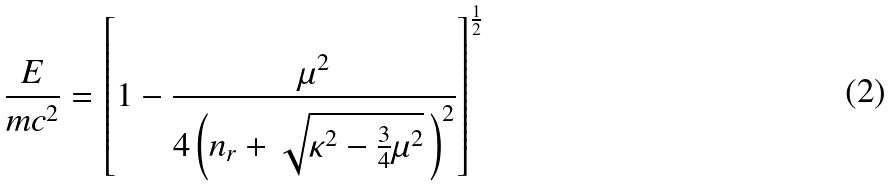<formula> <loc_0><loc_0><loc_500><loc_500>\frac { E } { m c ^ { 2 } } = \left [ 1 - \frac { \mu ^ { 2 } } { 4 \left ( n _ { r } + \sqrt { \kappa ^ { 2 } - \frac { 3 } { 4 } \mu ^ { 2 } } \, \right ) ^ { 2 } } \right ] ^ { \frac { 1 } { 2 } }</formula> 